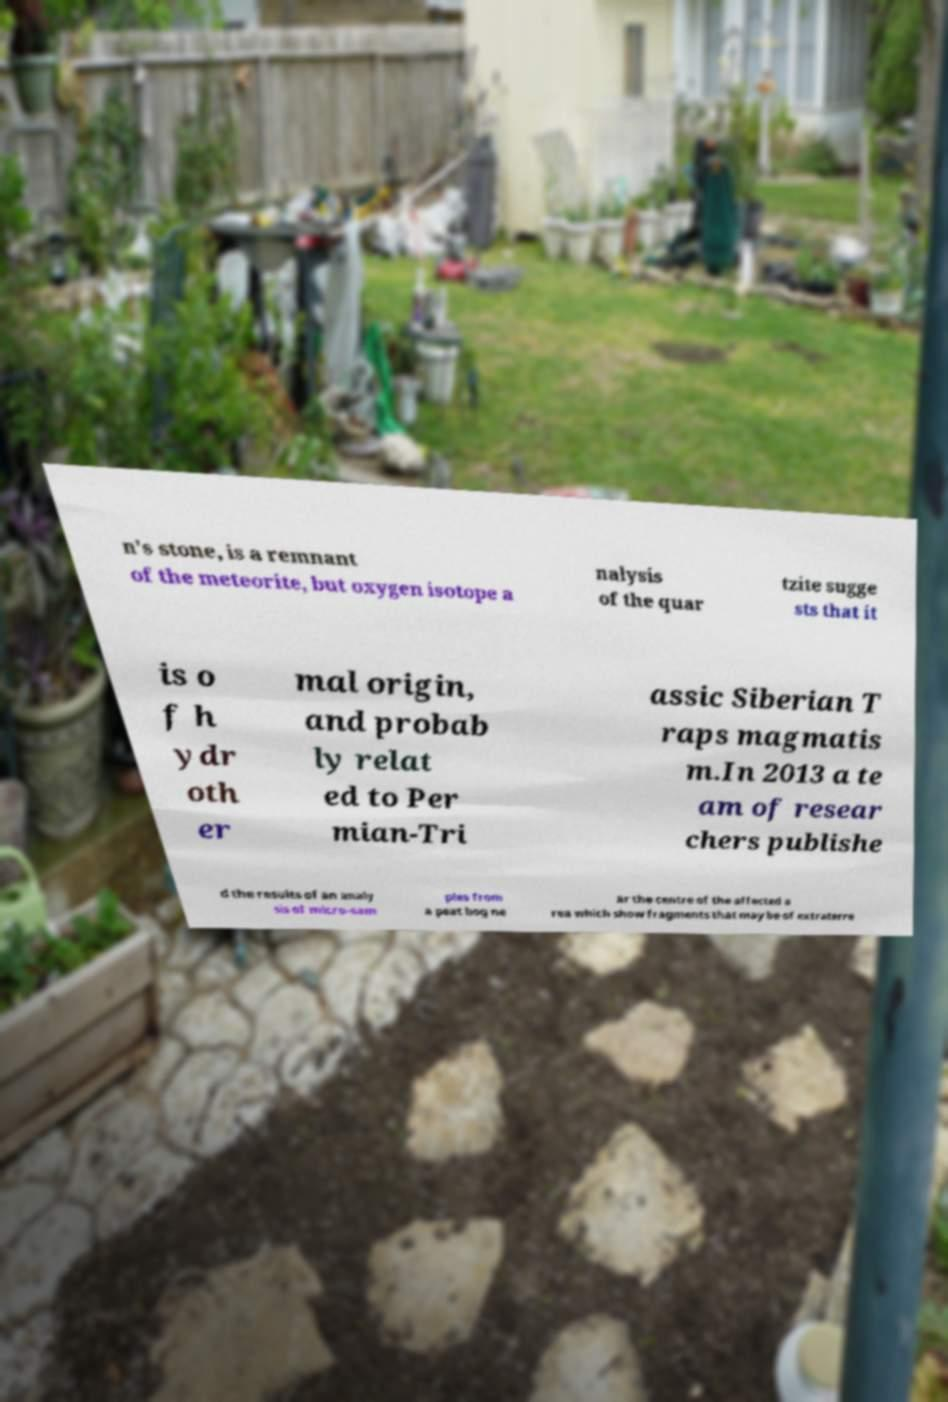For documentation purposes, I need the text within this image transcribed. Could you provide that? n's stone, is a remnant of the meteorite, but oxygen isotope a nalysis of the quar tzite sugge sts that it is o f h ydr oth er mal origin, and probab ly relat ed to Per mian-Tri assic Siberian T raps magmatis m.In 2013 a te am of resear chers publishe d the results of an analy sis of micro-sam ples from a peat bog ne ar the centre of the affected a rea which show fragments that may be of extraterre 